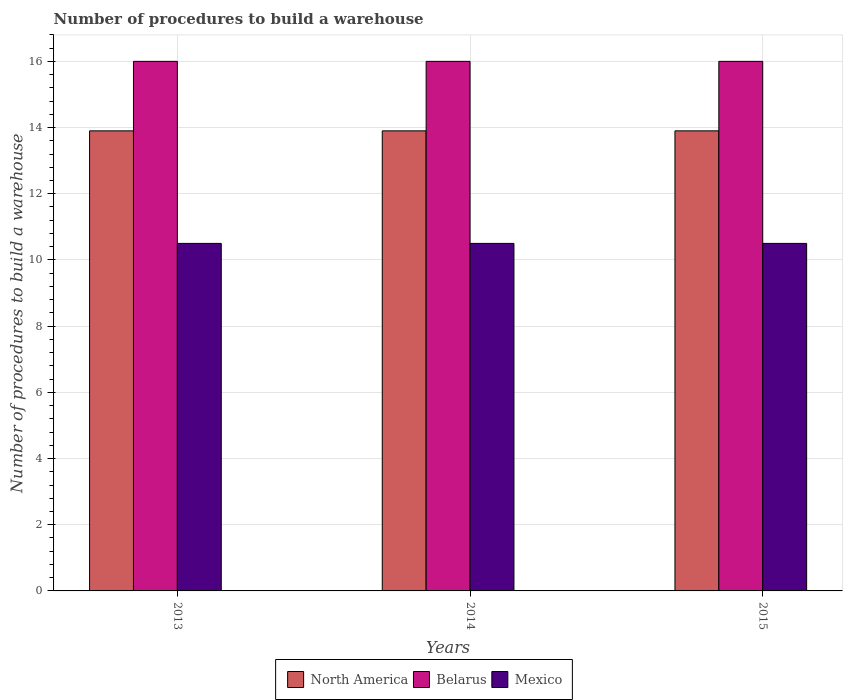How many groups of bars are there?
Provide a succinct answer. 3. Are the number of bars on each tick of the X-axis equal?
Your answer should be compact. Yes. How many bars are there on the 3rd tick from the left?
Make the answer very short. 3. In how many cases, is the number of bars for a given year not equal to the number of legend labels?
Your answer should be compact. 0. What is the number of procedures to build a warehouse in in Belarus in 2015?
Your answer should be compact. 16. In which year was the number of procedures to build a warehouse in in North America maximum?
Make the answer very short. 2013. What is the total number of procedures to build a warehouse in in North America in the graph?
Make the answer very short. 41.7. What is the difference between the number of procedures to build a warehouse in in North America in 2013 and that in 2015?
Your answer should be compact. 0. What is the average number of procedures to build a warehouse in in North America per year?
Make the answer very short. 13.9. In the year 2013, what is the difference between the number of procedures to build a warehouse in in Belarus and number of procedures to build a warehouse in in Mexico?
Keep it short and to the point. 5.5. In how many years, is the number of procedures to build a warehouse in in Mexico greater than 5.2?
Give a very brief answer. 3. Is the number of procedures to build a warehouse in in Belarus in 2013 less than that in 2014?
Offer a terse response. No. In how many years, is the number of procedures to build a warehouse in in North America greater than the average number of procedures to build a warehouse in in North America taken over all years?
Provide a short and direct response. 0. Is the sum of the number of procedures to build a warehouse in in Belarus in 2013 and 2015 greater than the maximum number of procedures to build a warehouse in in Mexico across all years?
Make the answer very short. Yes. What does the 2nd bar from the right in 2013 represents?
Make the answer very short. Belarus. What is the difference between two consecutive major ticks on the Y-axis?
Your response must be concise. 2. How are the legend labels stacked?
Keep it short and to the point. Horizontal. What is the title of the graph?
Provide a short and direct response. Number of procedures to build a warehouse. What is the label or title of the X-axis?
Give a very brief answer. Years. What is the label or title of the Y-axis?
Your answer should be very brief. Number of procedures to build a warehouse. What is the Number of procedures to build a warehouse in North America in 2013?
Offer a terse response. 13.9. What is the Number of procedures to build a warehouse of Belarus in 2013?
Keep it short and to the point. 16. What is the Number of procedures to build a warehouse in Mexico in 2013?
Your response must be concise. 10.5. What is the Number of procedures to build a warehouse of Belarus in 2014?
Keep it short and to the point. 16. What is the Number of procedures to build a warehouse of Mexico in 2014?
Ensure brevity in your answer.  10.5. Across all years, what is the maximum Number of procedures to build a warehouse of North America?
Keep it short and to the point. 13.9. Across all years, what is the maximum Number of procedures to build a warehouse of Belarus?
Offer a very short reply. 16. Across all years, what is the maximum Number of procedures to build a warehouse in Mexico?
Make the answer very short. 10.5. Across all years, what is the minimum Number of procedures to build a warehouse in North America?
Provide a short and direct response. 13.9. Across all years, what is the minimum Number of procedures to build a warehouse in Mexico?
Your answer should be compact. 10.5. What is the total Number of procedures to build a warehouse in North America in the graph?
Provide a succinct answer. 41.7. What is the total Number of procedures to build a warehouse of Mexico in the graph?
Provide a short and direct response. 31.5. What is the difference between the Number of procedures to build a warehouse of North America in 2013 and that in 2014?
Your answer should be very brief. 0. What is the difference between the Number of procedures to build a warehouse in North America in 2013 and that in 2015?
Keep it short and to the point. 0. What is the difference between the Number of procedures to build a warehouse in Belarus in 2013 and that in 2015?
Your answer should be very brief. 0. What is the difference between the Number of procedures to build a warehouse of Mexico in 2014 and that in 2015?
Give a very brief answer. 0. What is the difference between the Number of procedures to build a warehouse of North America in 2013 and the Number of procedures to build a warehouse of Belarus in 2014?
Your answer should be very brief. -2.1. What is the difference between the Number of procedures to build a warehouse in North America in 2013 and the Number of procedures to build a warehouse in Belarus in 2015?
Make the answer very short. -2.1. What is the difference between the Number of procedures to build a warehouse in North America in 2014 and the Number of procedures to build a warehouse in Belarus in 2015?
Your answer should be compact. -2.1. What is the difference between the Number of procedures to build a warehouse of North America in 2014 and the Number of procedures to build a warehouse of Mexico in 2015?
Offer a very short reply. 3.4. What is the average Number of procedures to build a warehouse in Belarus per year?
Your answer should be very brief. 16. In the year 2013, what is the difference between the Number of procedures to build a warehouse of North America and Number of procedures to build a warehouse of Belarus?
Provide a succinct answer. -2.1. In the year 2013, what is the difference between the Number of procedures to build a warehouse of North America and Number of procedures to build a warehouse of Mexico?
Provide a succinct answer. 3.4. In the year 2014, what is the difference between the Number of procedures to build a warehouse in Belarus and Number of procedures to build a warehouse in Mexico?
Give a very brief answer. 5.5. In the year 2015, what is the difference between the Number of procedures to build a warehouse of North America and Number of procedures to build a warehouse of Belarus?
Your answer should be very brief. -2.1. What is the ratio of the Number of procedures to build a warehouse in North America in 2013 to that in 2014?
Make the answer very short. 1. What is the ratio of the Number of procedures to build a warehouse in North America in 2013 to that in 2015?
Keep it short and to the point. 1. What is the ratio of the Number of procedures to build a warehouse of Mexico in 2013 to that in 2015?
Provide a succinct answer. 1. What is the ratio of the Number of procedures to build a warehouse of Mexico in 2014 to that in 2015?
Keep it short and to the point. 1. What is the difference between the highest and the second highest Number of procedures to build a warehouse of Mexico?
Make the answer very short. 0. What is the difference between the highest and the lowest Number of procedures to build a warehouse of Mexico?
Provide a succinct answer. 0. 